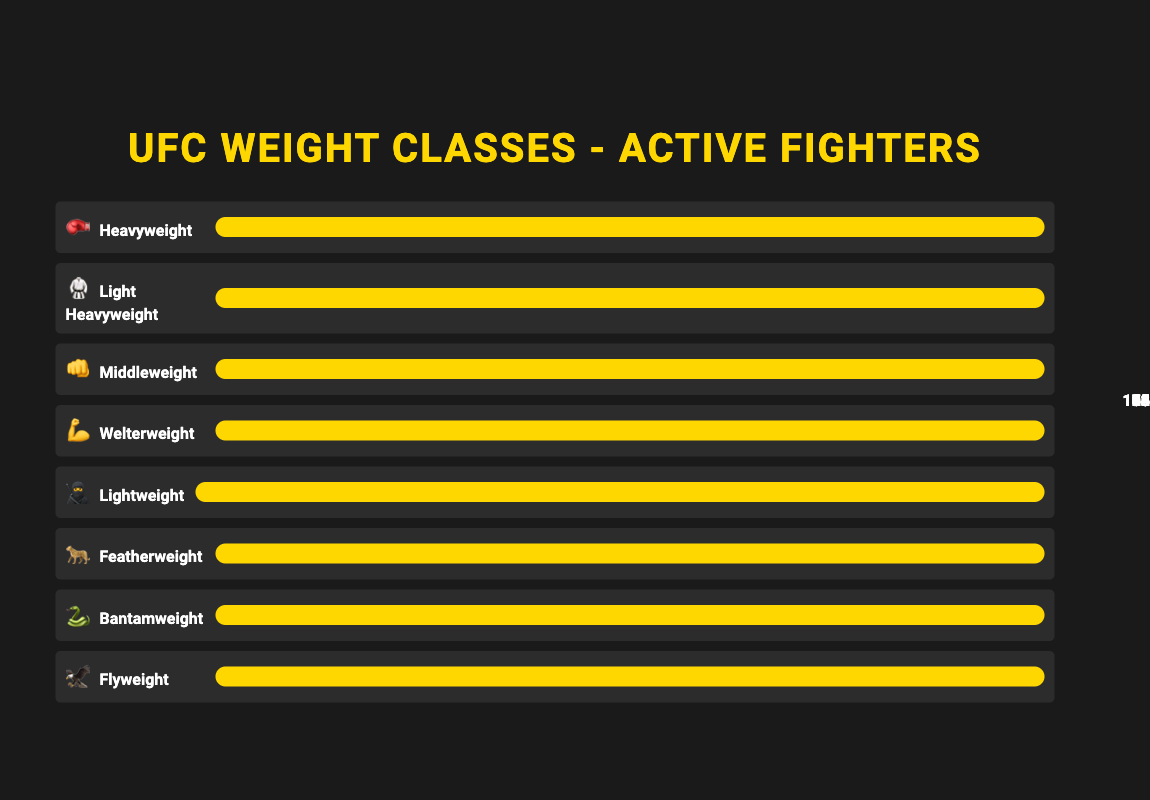Which weight class has the most active fighters? The width of the bars indicates the number of fighters. The Lightweight class has the longest bar, showing it has the most fighters.
Answer: Lightweight What's the total number of active fighters across all weight classes? Adding up the fighters from all weight classes: 48 (Heavyweight) + 62 (Light Heavyweight) + 85 (Middleweight) + 104 (Welterweight) + 125 (Lightweight) + 93 (Featherweight) + 78 (Bantamweight) + 56 (Flyweight) = 651
Answer: 651 Which weight class has the fewest active fighters? The Heavyweight class has the shortest bar with 48 fighters, which is the fewest.
Answer: Heavyweight How many more active fighters are there in the Lightweight class compared to the Heavyweight class? Subtract the number of Heavyweight fighters from the number of Lightweight fighters: 125 (Lightweight) - 48 (Heavyweight) = 77
Answer: 77 Which weight class has the second-most active fighters? The Welterweight class has the second longest bar at 104 fighters, making it the second-most.
Answer: Welterweight What's the median number of active fighters across all weight classes? First, arrange the numbers in ascending order: 48, 56, 62, 78, 85, 93, 104, 125. The middle numbers are 78 and 85. The median is (78 + 85) / 2 = 81.5
Answer: 81.5 How many fighters are there in weight classes with fewer than 80 active fighters? Add up the fighters in Flyweight (56), Heavyweight (48), and Light Heavyweight (62) because they have fewer than 80 fighters: 56 + 48 + 62 = 166
Answer: 166 Which weight class has an emoji depicting an animal? The Featherweight class is represented by the "🐆" emoji, an animal.
Answer: Featherweight What is the ratio of Lightweight to Flyweight fighters? Divide the number of Lightweight fighters by Flyweight fighters: 125 (Lightweight) / 56 (Flyweight) ≈ 2.23
Answer: 2.23 If the number of Bantamweight fighters increased by 10, how many would there be? Add 10 to the current number of Bantamweight fighters: 78 + 10 = 88
Answer: 88 